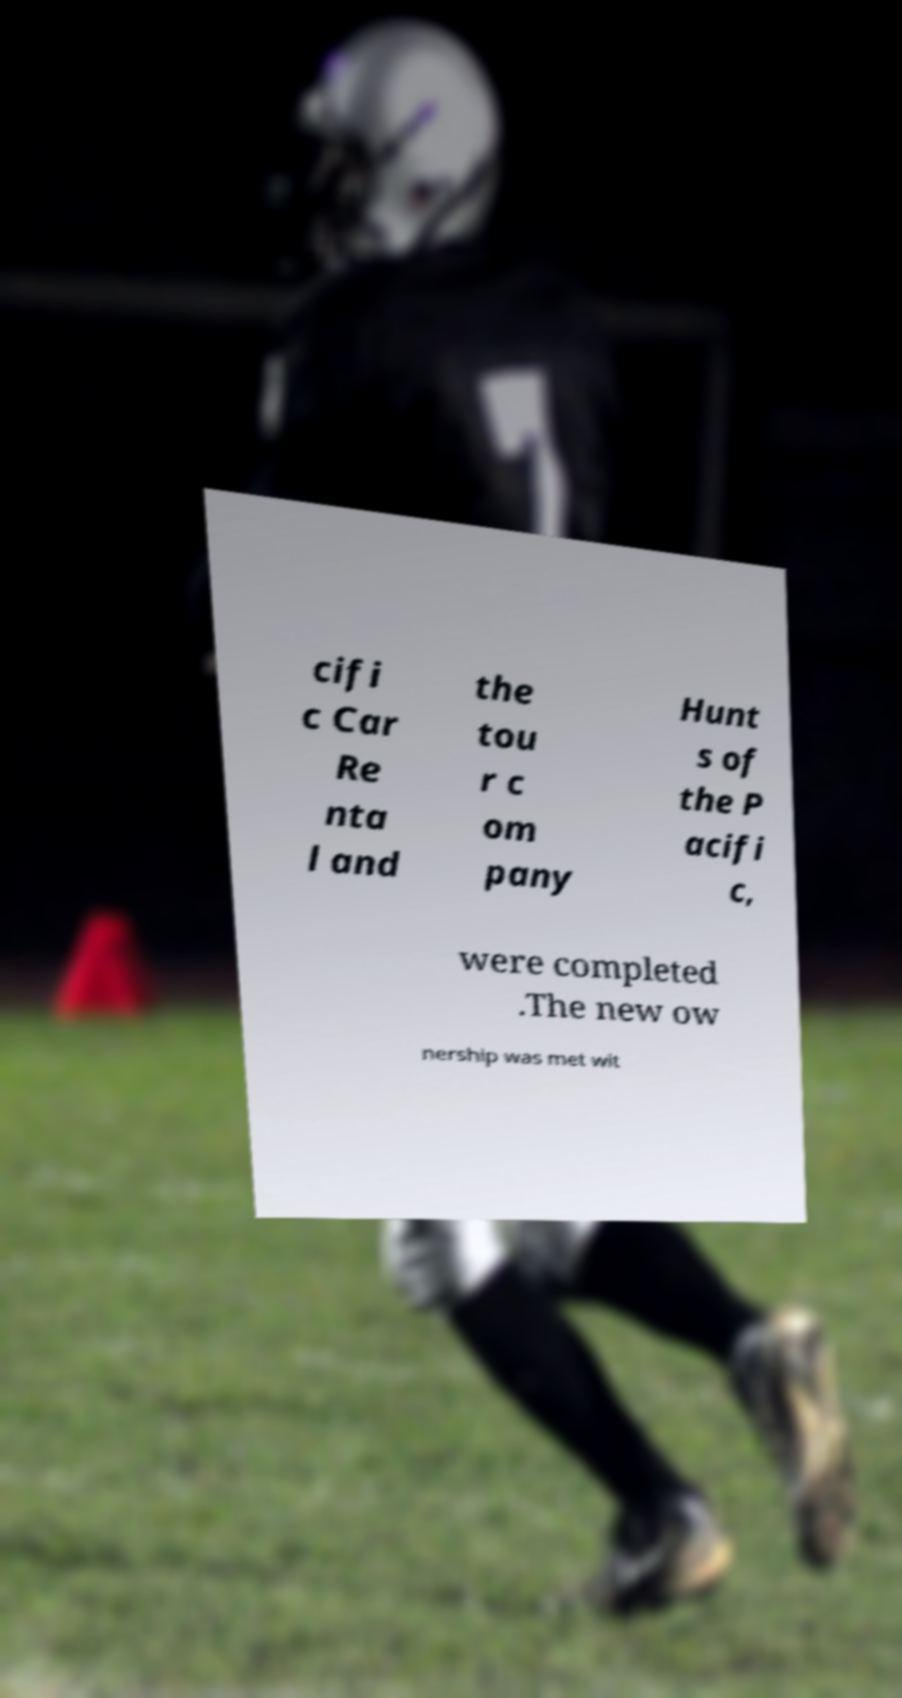I need the written content from this picture converted into text. Can you do that? cifi c Car Re nta l and the tou r c om pany Hunt s of the P acifi c, were completed .The new ow nership was met wit 